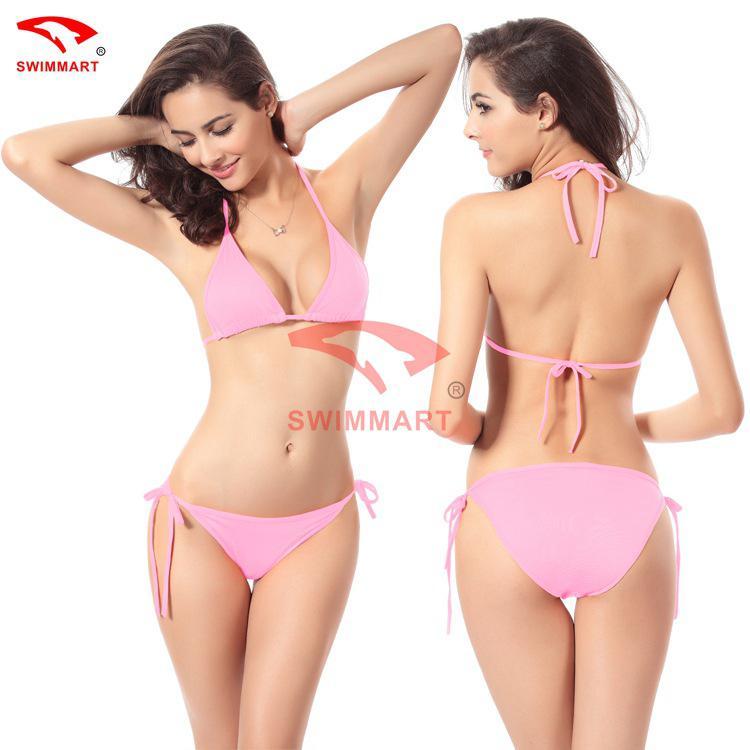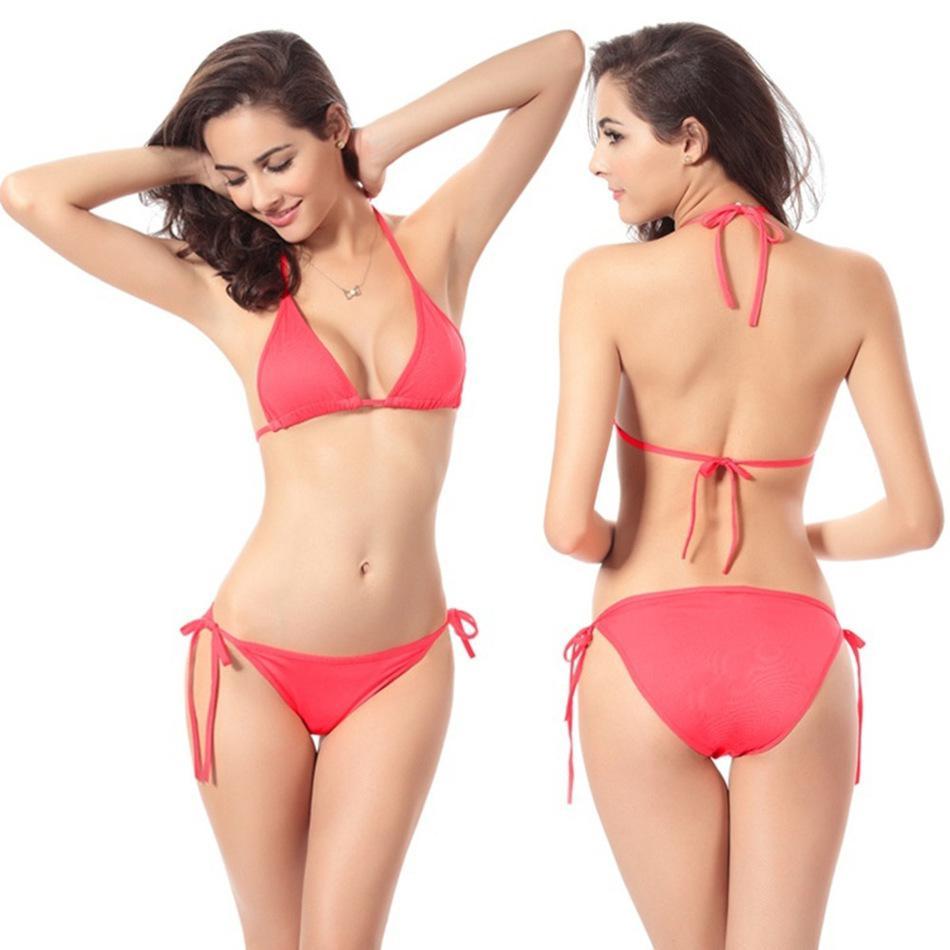The first image is the image on the left, the second image is the image on the right. Evaluate the accuracy of this statement regarding the images: "You can see a swimming pool behind at least one of the models.". Is it true? Answer yes or no. No. 